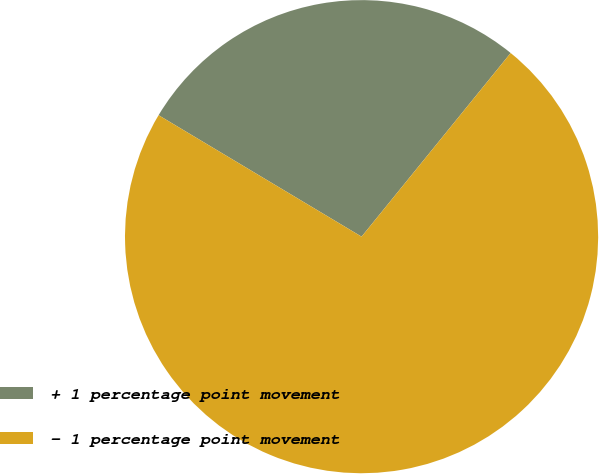Convert chart to OTSL. <chart><loc_0><loc_0><loc_500><loc_500><pie_chart><fcel>+ 1 percentage point movement<fcel>- 1 percentage point movement<nl><fcel>27.27%<fcel>72.73%<nl></chart> 